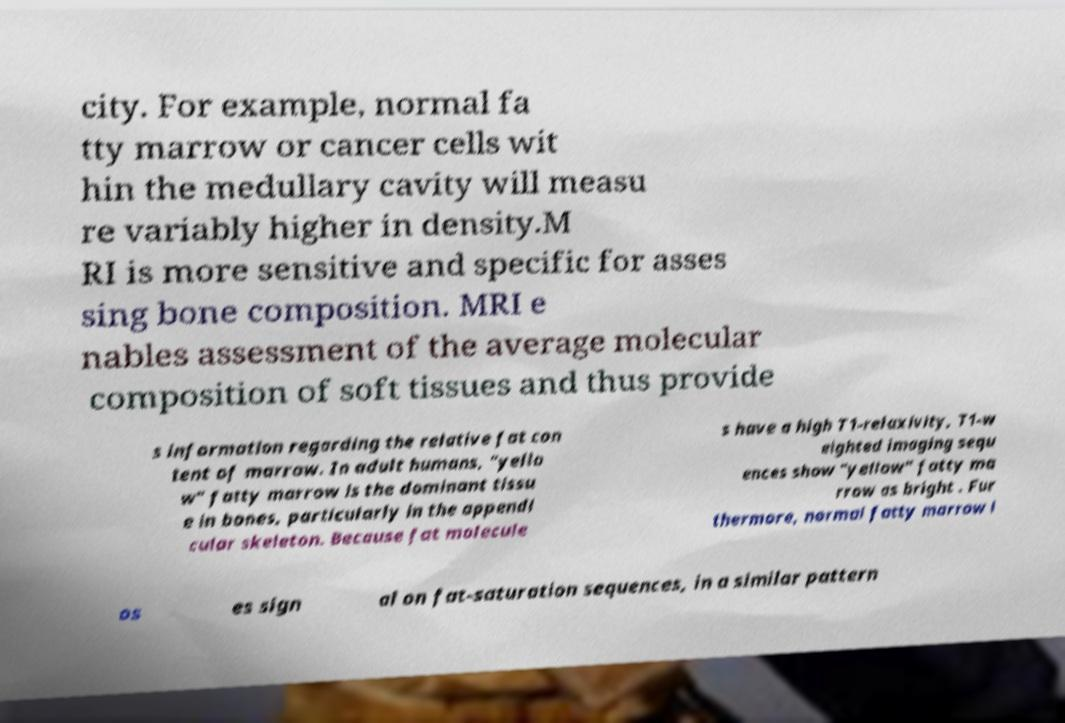I need the written content from this picture converted into text. Can you do that? city. For example, normal fa tty marrow or cancer cells wit hin the medullary cavity will measu re variably higher in density.M RI is more sensitive and specific for asses sing bone composition. MRI e nables assessment of the average molecular composition of soft tissues and thus provide s information regarding the relative fat con tent of marrow. In adult humans, "yello w" fatty marrow is the dominant tissu e in bones, particularly in the appendi cular skeleton. Because fat molecule s have a high T1-relaxivity, T1-w eighted imaging sequ ences show "yellow" fatty ma rrow as bright . Fur thermore, normal fatty marrow l os es sign al on fat-saturation sequences, in a similar pattern 